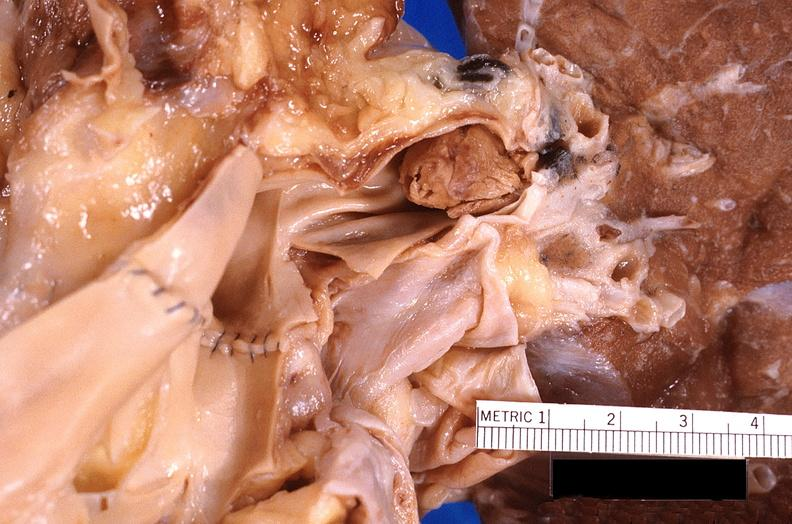what is present?
Answer the question using a single word or phrase. Respiratory 